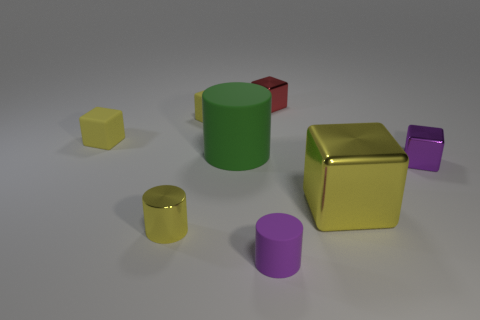What material is the cylinder that is the same color as the big metallic block?
Keep it short and to the point. Metal. How many shiny cubes are there?
Your response must be concise. 3. Is the number of tiny gray cubes less than the number of small purple metal blocks?
Provide a short and direct response. Yes. There is a red cube that is the same size as the purple shiny cube; what is it made of?
Offer a very short reply. Metal. What number of things are either large green blocks or matte things?
Offer a very short reply. 4. How many tiny rubber objects are both to the left of the large green matte cylinder and in front of the green matte cylinder?
Provide a succinct answer. 0. Are there fewer small red metal things in front of the green cylinder than rubber objects?
Make the answer very short. Yes. What shape is the purple rubber thing that is the same size as the yellow cylinder?
Offer a very short reply. Cylinder. How many other objects are the same color as the metallic cylinder?
Your answer should be compact. 3. Is the purple shiny block the same size as the green matte cylinder?
Offer a terse response. No. 